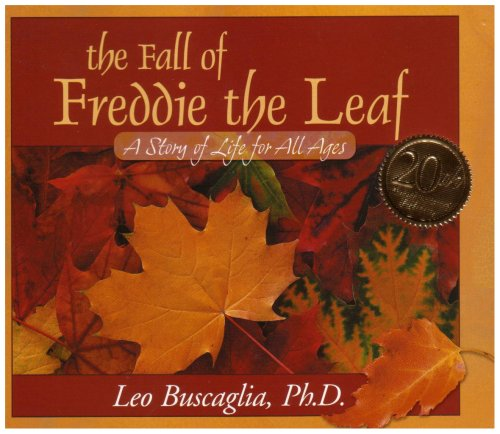What is the genre of this book? While initially appearing as a children's book, 'The Fall of Freddie the Leaf' is widely appreciated as a self-help and philosophical book, discussing themes of life, change, and purpose, which resonate across all ages. 